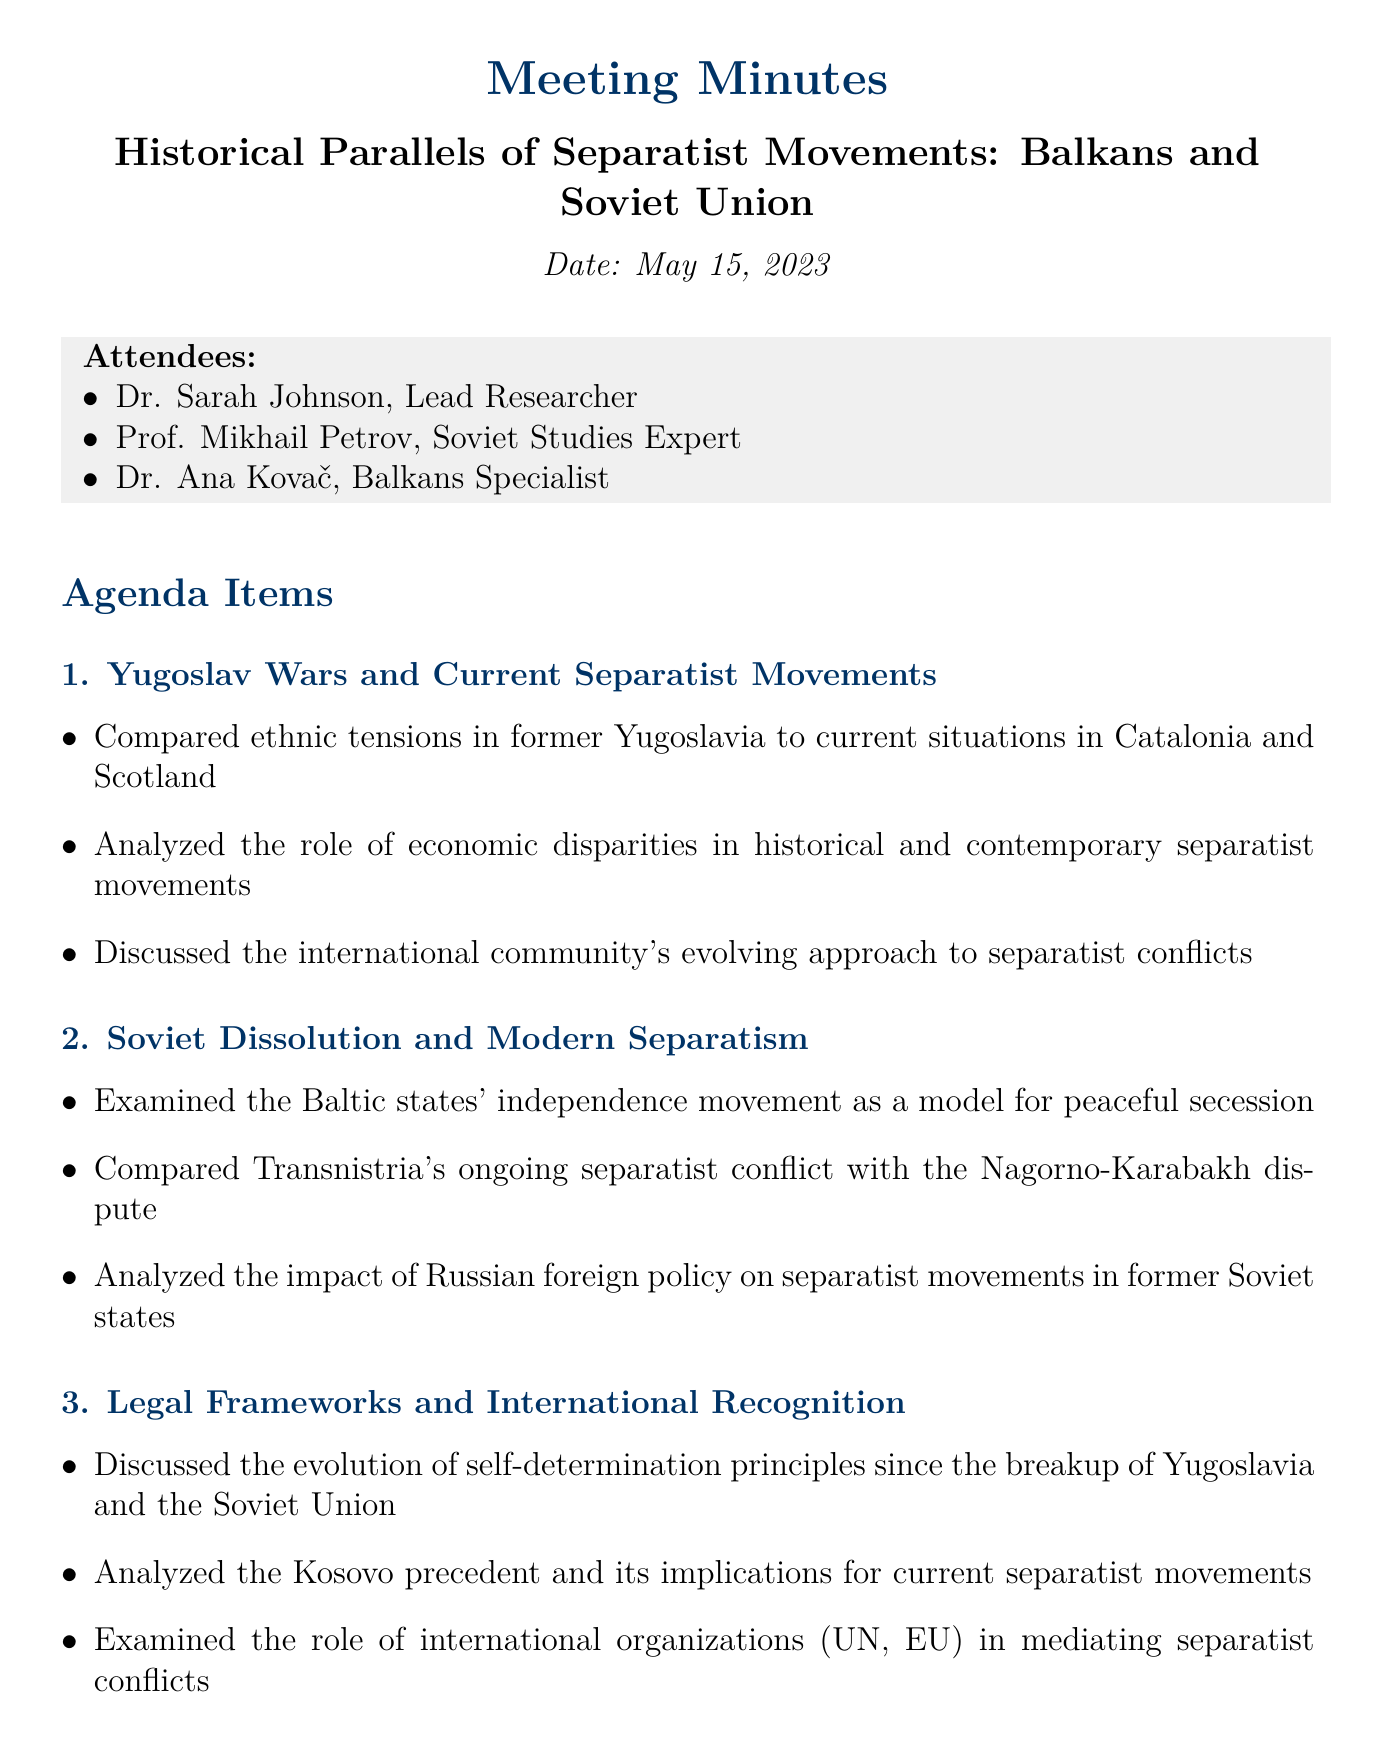What is the date of the meeting? The date of the meeting is specifically mentioned in the document as "May 15, 2023."
Answer: May 15, 2023 Who is the lead researcher? The document specifies that Dr. Sarah Johnson is the lead researcher in the meeting.
Answer: Dr. Sarah Johnson Which agenda item discusses the role of economic disparities? This key point is mentioned under the agenda item regarding "Yugoslav Wars and Current Separatist Movements."
Answer: Yugoslav Wars and Current Separatist Movements What is one of the action items agreed upon in the meeting? The document lists several action items, one of which is to "Prepare comparative case study on Catalan independence movement and Slovenia's secession from Yugoslavia."
Answer: Prepare comparative case study on Catalan independence movement and Slovenia's secession from Yugoslavia What topic is analyzed in relation to the Baltic states? The document specifies that the agenda item discusses "Baltic states' independence movement as a model for peaceful secession."
Answer: Baltic states' independence movement Which participants are attending the meeting? The document lists three attendees, one being Prof. Mikhail Petrov.
Answer: Prof. Mikhail Petrov What is the next meeting date? The next meeting date is clearly stated in the document as "June 5, 2023."
Answer: June 5, 2023 What principle is discussed regarding the evolution of self-determination? The discussion is focused on the evolution of "self-determination principles" since the breakup of Yugoslavia and the Soviet Union.
Answer: self-determination principles 